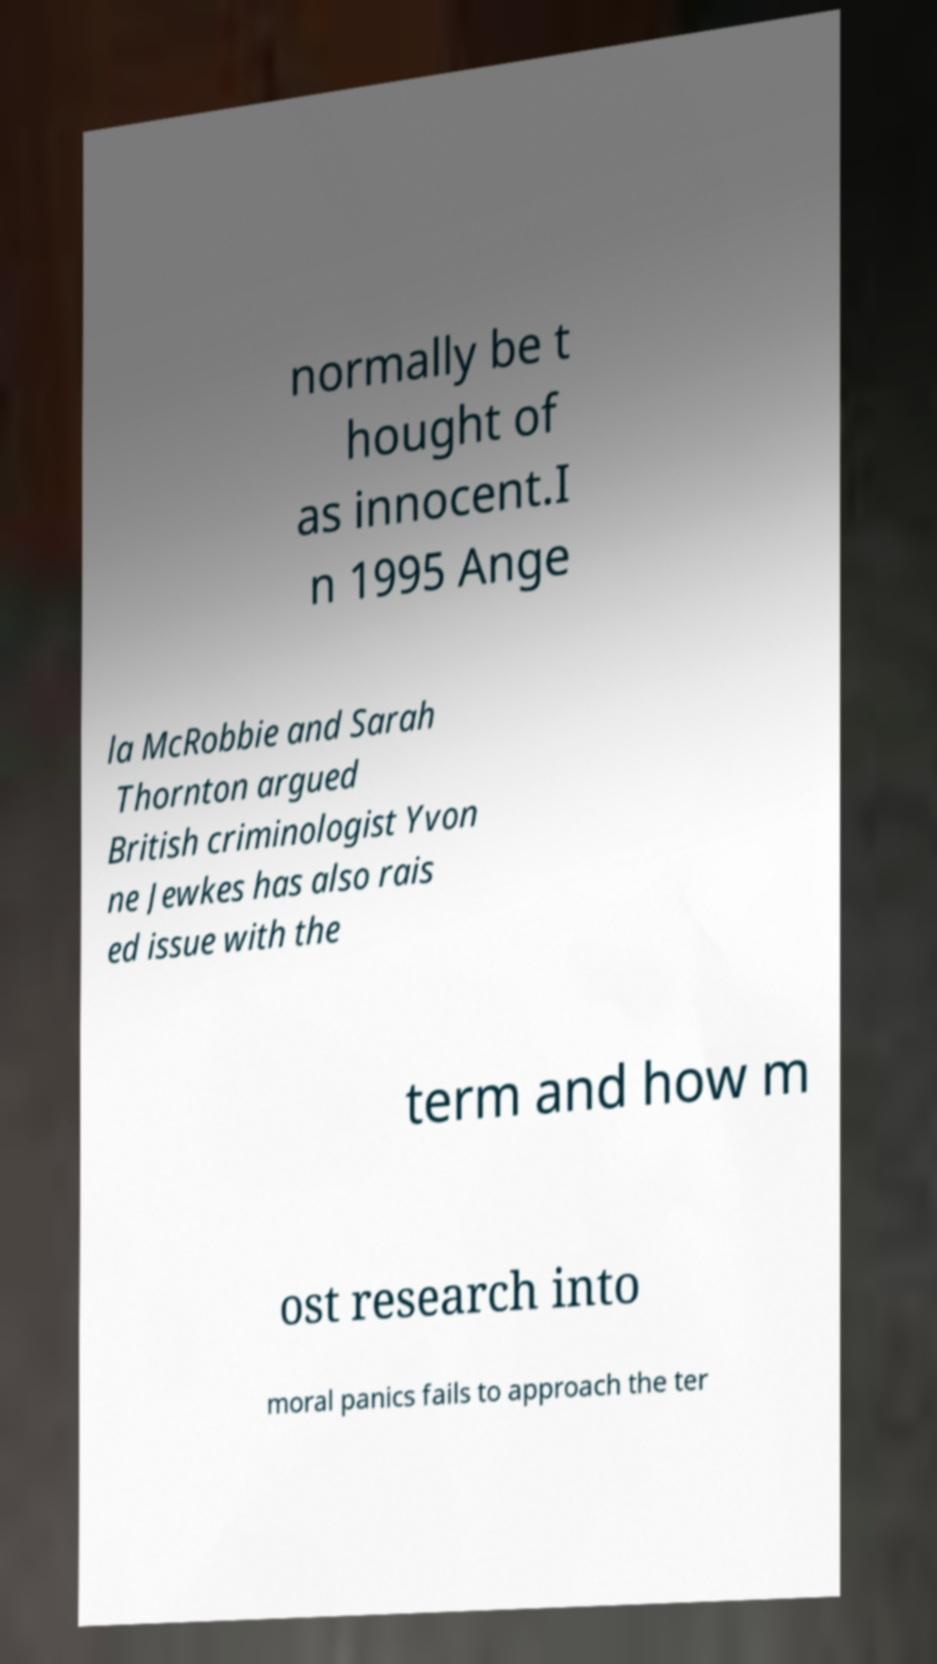Can you accurately transcribe the text from the provided image for me? normally be t hought of as innocent.I n 1995 Ange la McRobbie and Sarah Thornton argued British criminologist Yvon ne Jewkes has also rais ed issue with the term and how m ost research into moral panics fails to approach the ter 